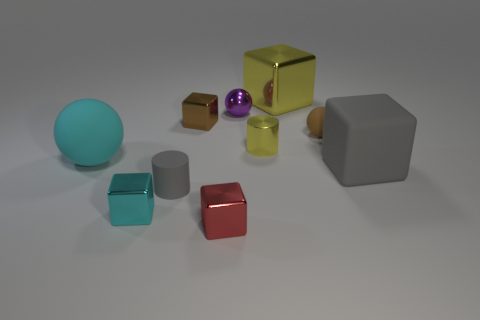Subtract all gray cubes. How many cubes are left? 4 Subtract all gray blocks. How many blocks are left? 4 Subtract all green cubes. Subtract all green balls. How many cubes are left? 5 Subtract all cylinders. How many objects are left? 8 Add 4 yellow shiny cylinders. How many yellow shiny cylinders exist? 5 Subtract 0 green blocks. How many objects are left? 10 Subtract all cyan rubber cylinders. Subtract all red metal blocks. How many objects are left? 9 Add 7 small red metallic cubes. How many small red metallic cubes are left? 8 